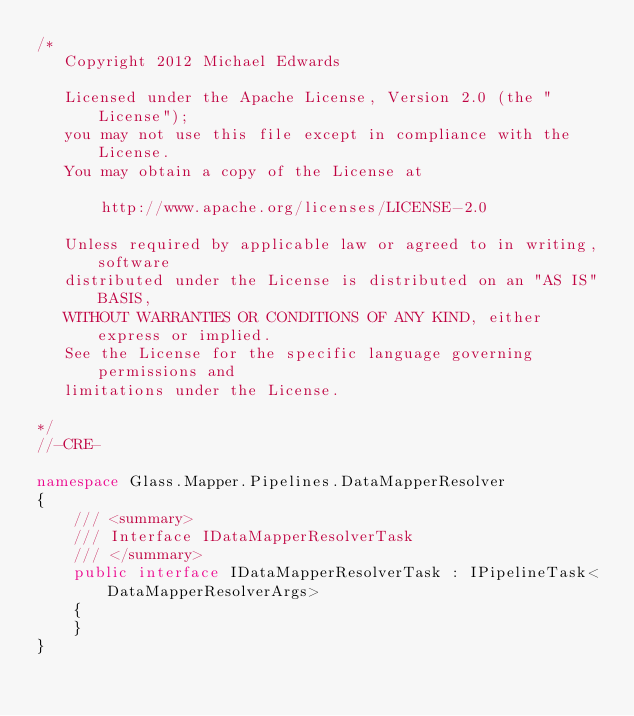Convert code to text. <code><loc_0><loc_0><loc_500><loc_500><_C#_>/*
   Copyright 2012 Michael Edwards
 
   Licensed under the Apache License, Version 2.0 (the "License");
   you may not use this file except in compliance with the License.
   You may obtain a copy of the License at

       http://www.apache.org/licenses/LICENSE-2.0

   Unless required by applicable law or agreed to in writing, software
   distributed under the License is distributed on an "AS IS" BASIS,
   WITHOUT WARRANTIES OR CONDITIONS OF ANY KIND, either express or implied.
   See the License for the specific language governing permissions and
   limitations under the License.
 
*/ 
//-CRE-

namespace Glass.Mapper.Pipelines.DataMapperResolver
{
    /// <summary>
    /// Interface IDataMapperResolverTask
    /// </summary>
    public interface IDataMapperResolverTask : IPipelineTask<DataMapperResolverArgs>
    {
    }
}




</code> 